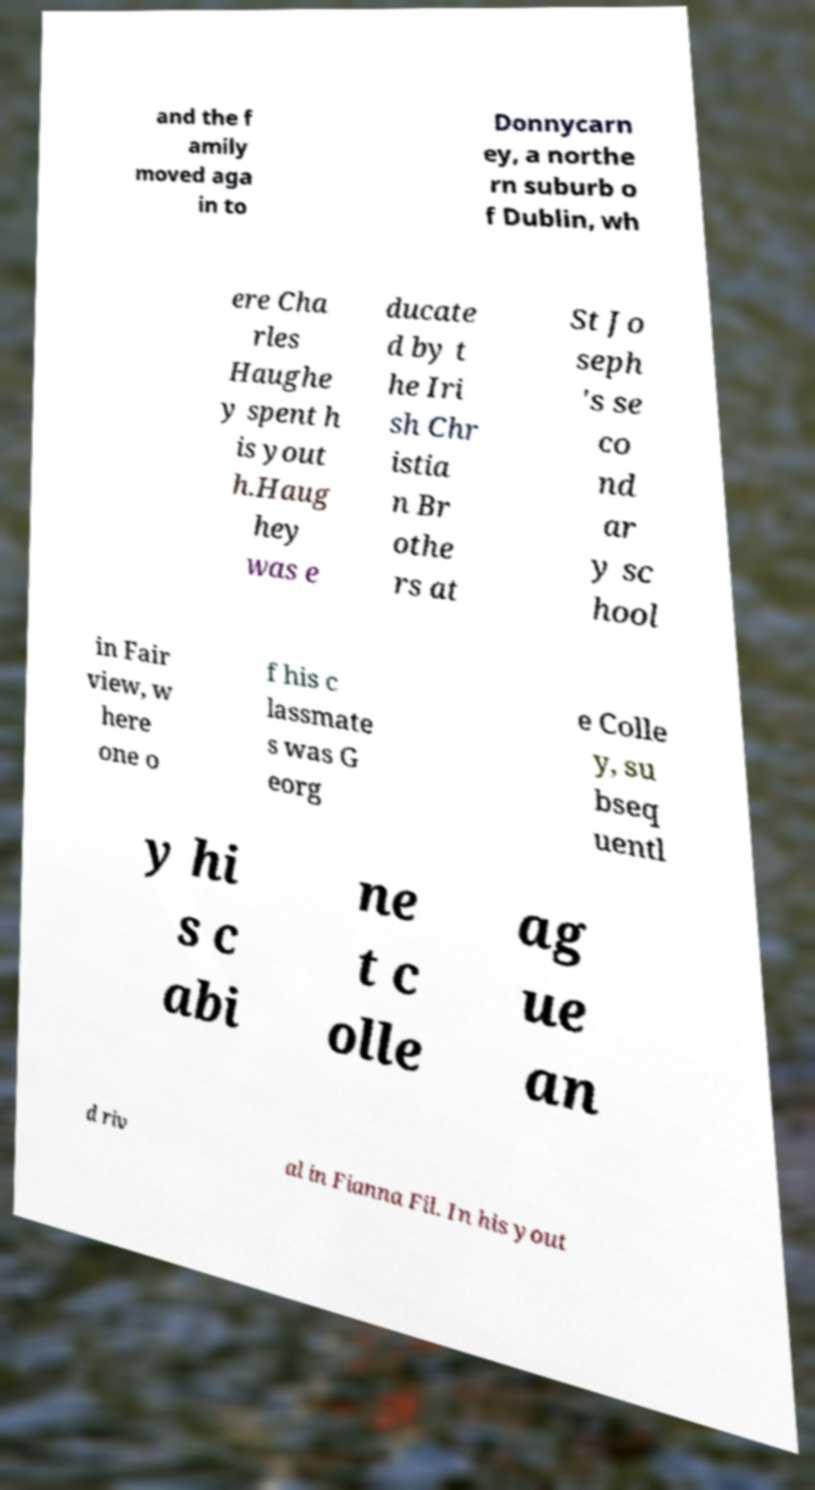Could you assist in decoding the text presented in this image and type it out clearly? and the f amily moved aga in to Donnycarn ey, a northe rn suburb o f Dublin, wh ere Cha rles Haughe y spent h is yout h.Haug hey was e ducate d by t he Iri sh Chr istia n Br othe rs at St Jo seph 's se co nd ar y sc hool in Fair view, w here one o f his c lassmate s was G eorg e Colle y, su bseq uentl y hi s c abi ne t c olle ag ue an d riv al in Fianna Fil. In his yout 